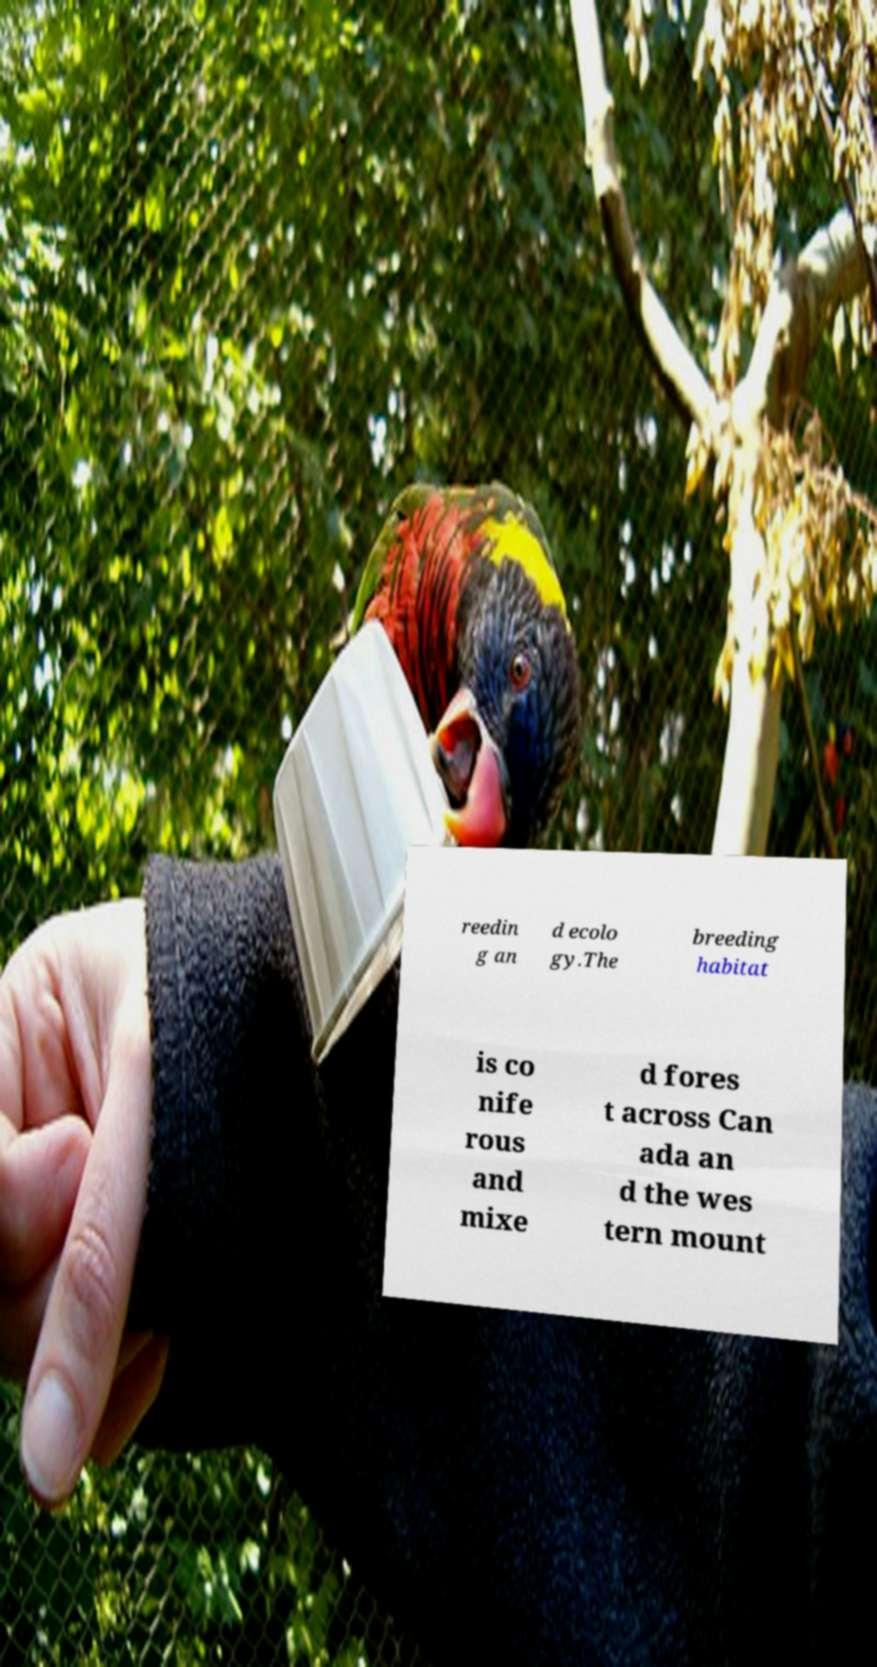There's text embedded in this image that I need extracted. Can you transcribe it verbatim? reedin g an d ecolo gy.The breeding habitat is co nife rous and mixe d fores t across Can ada an d the wes tern mount 